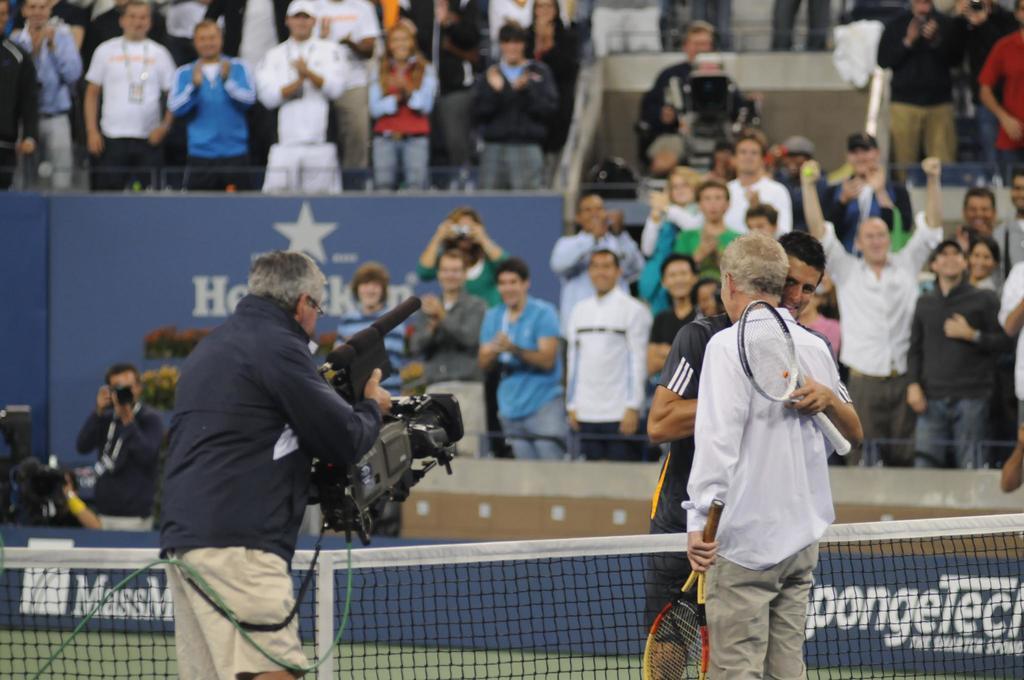What is written on the banner on the bottom right?
Your answer should be compact. Spongetech. What type of sporting event is this?
Offer a terse response. Answering does not require reading text in the image. 